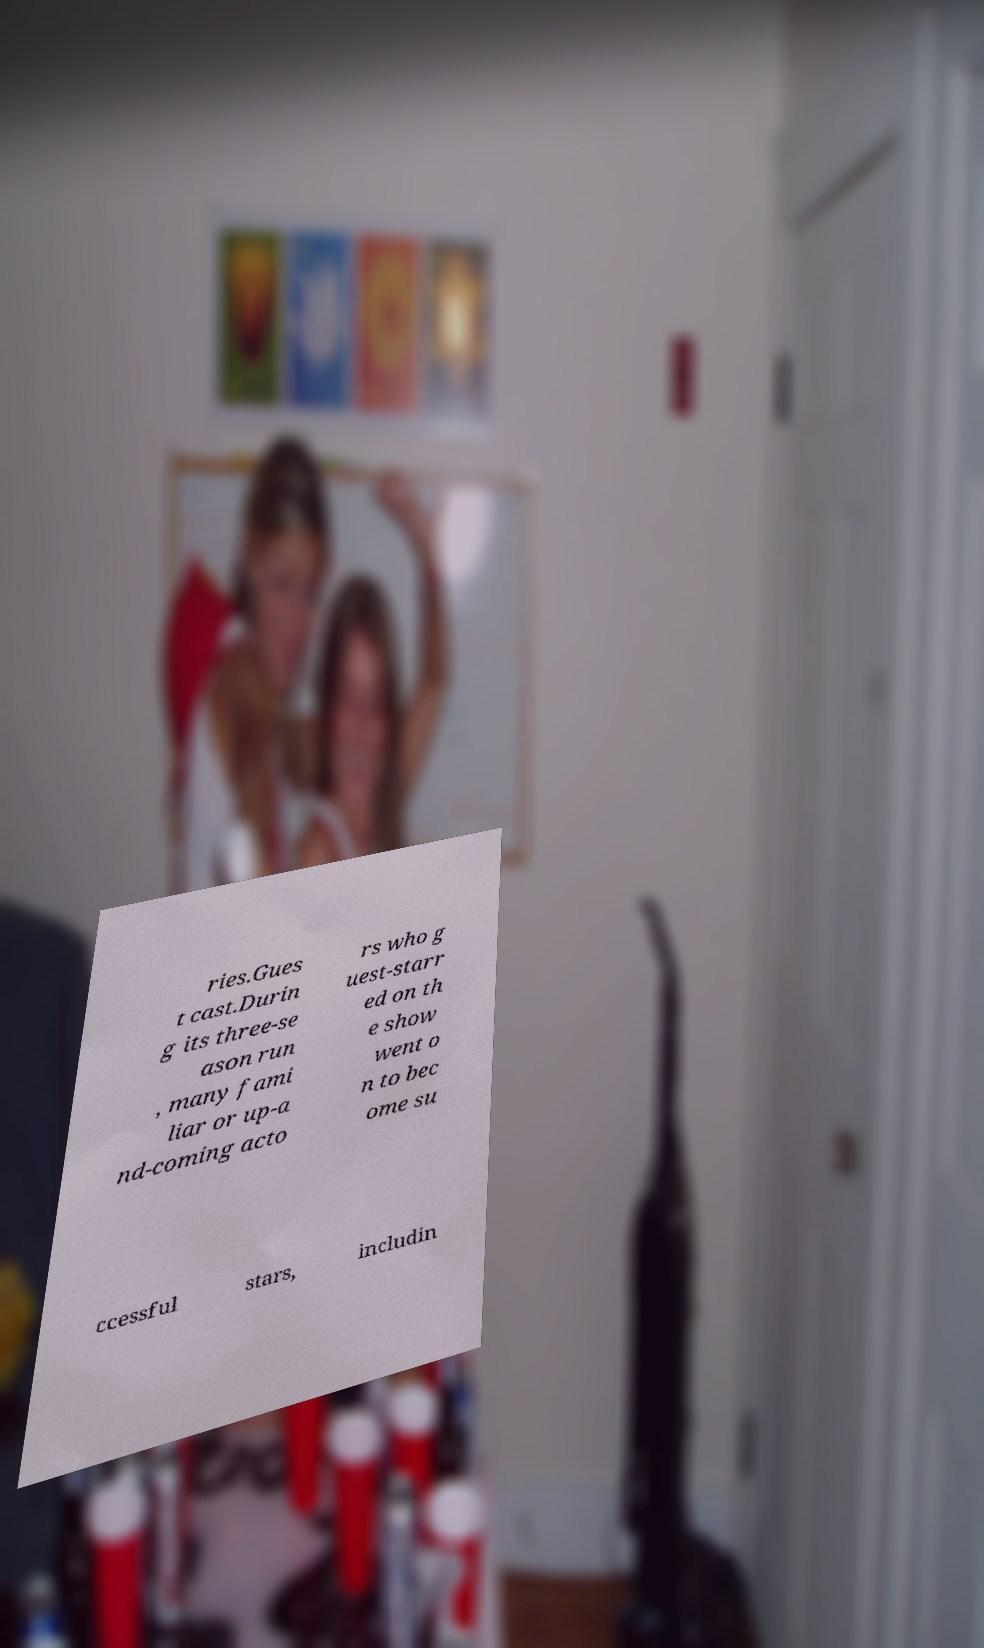Please identify and transcribe the text found in this image. ries.Gues t cast.Durin g its three-se ason run , many fami liar or up-a nd-coming acto rs who g uest-starr ed on th e show went o n to bec ome su ccessful stars, includin 